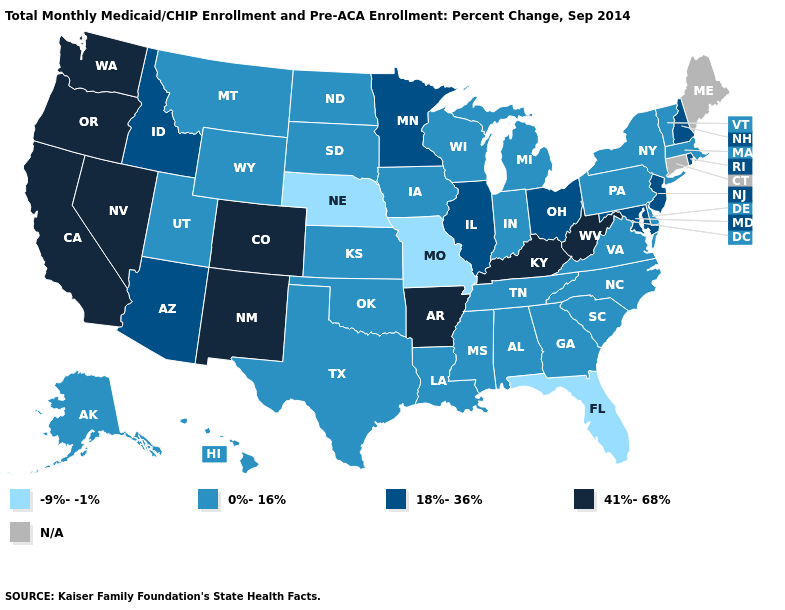Does the first symbol in the legend represent the smallest category?
Keep it brief. Yes. Name the states that have a value in the range -9%--1%?
Give a very brief answer. Florida, Missouri, Nebraska. Among the states that border Colorado , does Kansas have the lowest value?
Quick response, please. No. Which states have the highest value in the USA?
Answer briefly. Arkansas, California, Colorado, Kentucky, Nevada, New Mexico, Oregon, Washington, West Virginia. How many symbols are there in the legend?
Concise answer only. 5. Name the states that have a value in the range 0%-16%?
Quick response, please. Alabama, Alaska, Delaware, Georgia, Hawaii, Indiana, Iowa, Kansas, Louisiana, Massachusetts, Michigan, Mississippi, Montana, New York, North Carolina, North Dakota, Oklahoma, Pennsylvania, South Carolina, South Dakota, Tennessee, Texas, Utah, Vermont, Virginia, Wisconsin, Wyoming. What is the lowest value in the MidWest?
Answer briefly. -9%--1%. Does Missouri have the lowest value in the USA?
Be succinct. Yes. Does the first symbol in the legend represent the smallest category?
Write a very short answer. Yes. What is the value of Oregon?
Quick response, please. 41%-68%. What is the value of Mississippi?
Keep it brief. 0%-16%. Is the legend a continuous bar?
Short answer required. No. What is the value of California?
Write a very short answer. 41%-68%. Does Kentucky have the lowest value in the USA?
Concise answer only. No. Which states have the highest value in the USA?
Keep it brief. Arkansas, California, Colorado, Kentucky, Nevada, New Mexico, Oregon, Washington, West Virginia. 